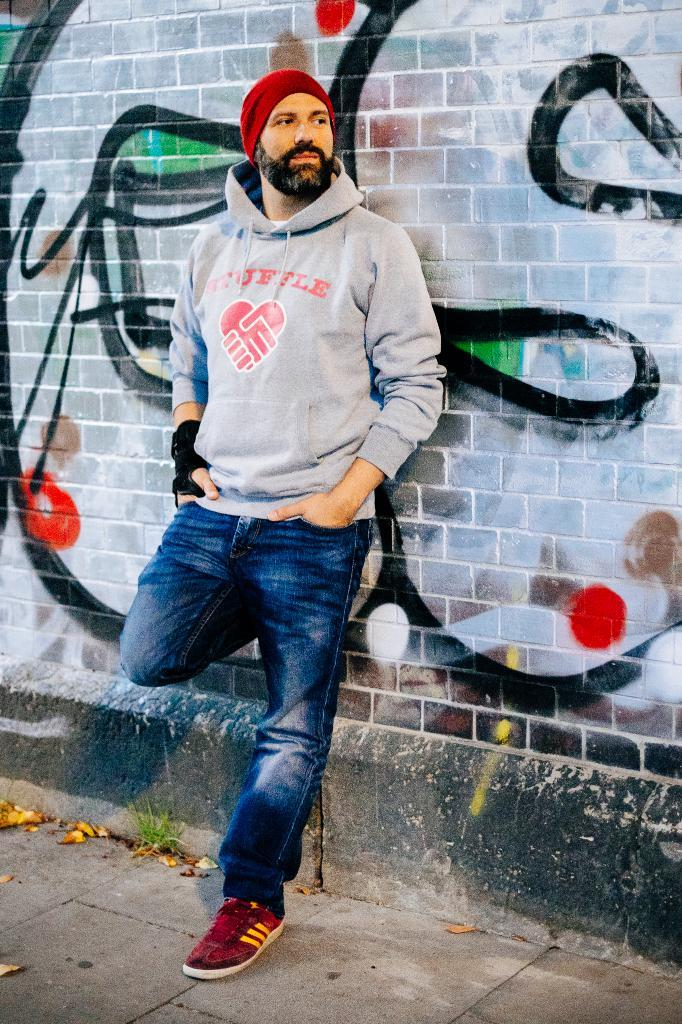Who is present in the image? There is a man in the image. What is the man doing in the image? The man is standing at a wall. What type of clothing is the man wearing? The man is wearing a jacket and a hat. What can be seen on the wall in the image? There is a painting on the wall. What type of ice can be seen melting on the man's hat in the image? There is no ice present on the man's hat in the image. How many frogs are sitting on the man's shoulder in the image? There are no frogs present in the image. 